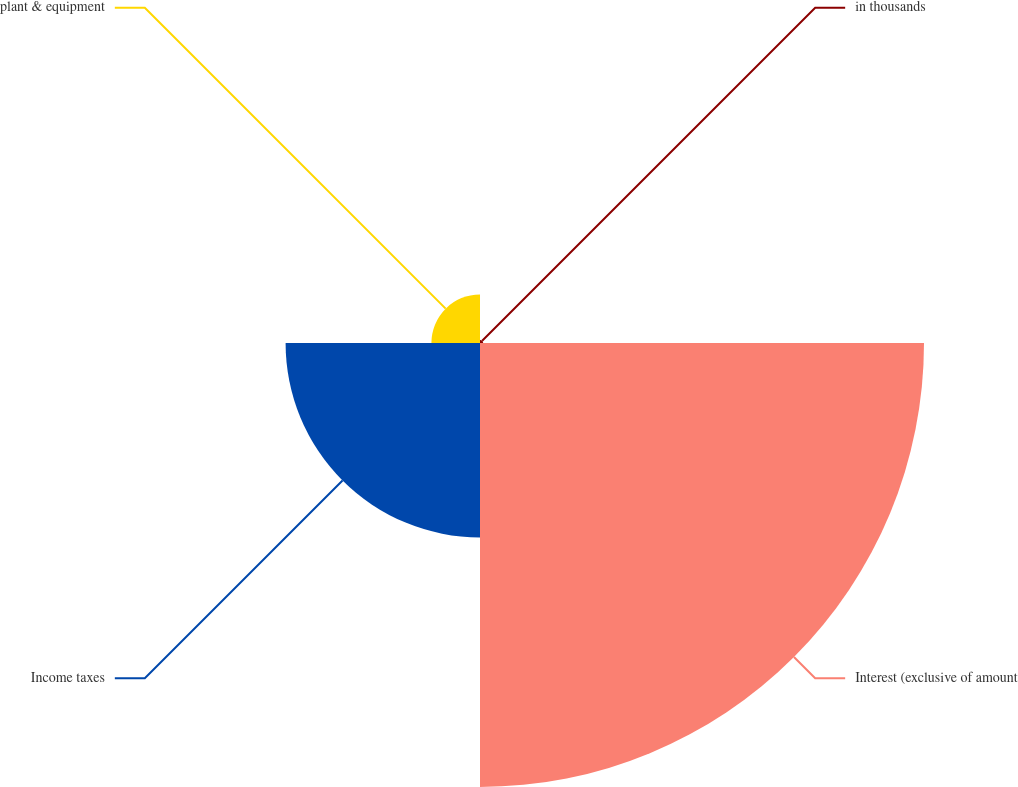Convert chart. <chart><loc_0><loc_0><loc_500><loc_500><pie_chart><fcel>in thousands<fcel>Interest (exclusive of amount<fcel>Income taxes<fcel>plant & equipment<nl><fcel>0.45%<fcel>64.34%<fcel>28.17%<fcel>7.04%<nl></chart> 